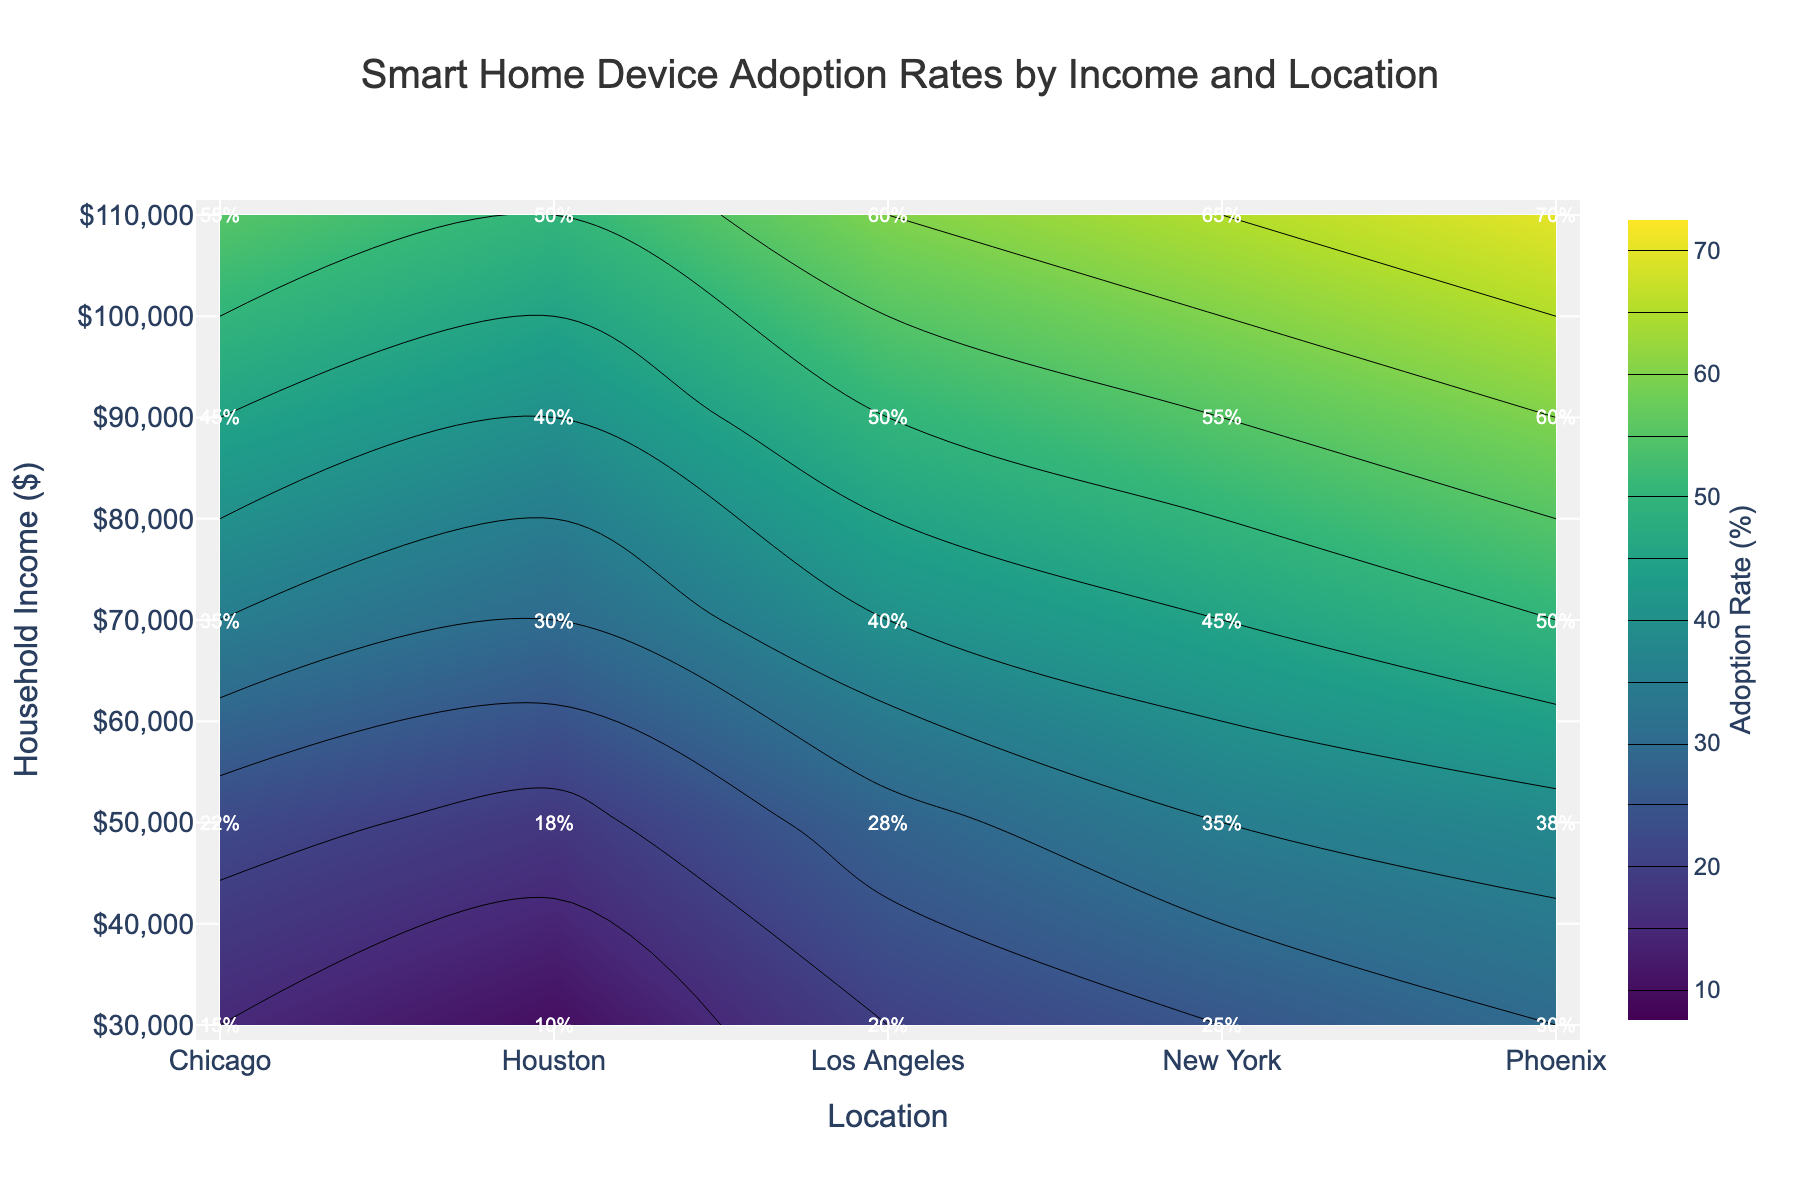What is the title of the figure? Look at the top part of the plot where the title is prominently displayed in large font. It reads "Smart Home Device Adoption Rates by Income and Location".
Answer: Smart Home Device Adoption Rates by Income and Location What is the contour plot’s color scale representing? The color scale, located next to the plot, indicates that it represents the Adoption Rate (%) of smart home devices.
Answer: Adoption Rate (%) Which city shows the highest adoption rate of smart home devices? Referring to the color intensities and labeled rates, Phoenix exhibits the highest adoption rate with one of the contour labels showing 70%.
Answer: Phoenix Which household income group has the lowest adoption rate? By examining the lowest end of the contour color scale, the $20,000-$39,999 income group in Houston shows the lowest adoption rate of 10%.
Answer: $20,000-$39,999 How does the adoption rate in New York differ for the highest and lowest income groups? Compare the labeled adoption rates for New York at the $20,000-$39,999 group and the $100,000-$119,999 group. The rates are 25% and 65%, respectively.
Answer: 40% difference What is the average adoption rate of smart home devices in Chicago across all income groups? Sum the adoption rates for Chicago: 15% + 22% + 35% + 45% + 55% = 172%, then divide by the number of groups, 5. The average is 172/5 = 34.4%.
Answer: 34.4% Which location has the flattest rate of adoption as household income increases? By observing the contours, note that Houston's contours are the most evenly spaced without steep changes between income levels. Examine the step increments between rates closely.
Answer: Houston How many locations appear to have at least one household income group with an adoption rate above 60%? Check the contour labels for values exceeding 60%. Only Phoenix and New York have adoption rates reaching or exceeding this threshold.
Answer: 2 locations Which household income group in Los Angeles has the highest adoption rate? Check labeled points in Los Angeles and find the maximum value. The highest adoption rate in Los Angeles is 60% at the $100,000-$119,999 income group.
Answer: $100,000-$119,999 